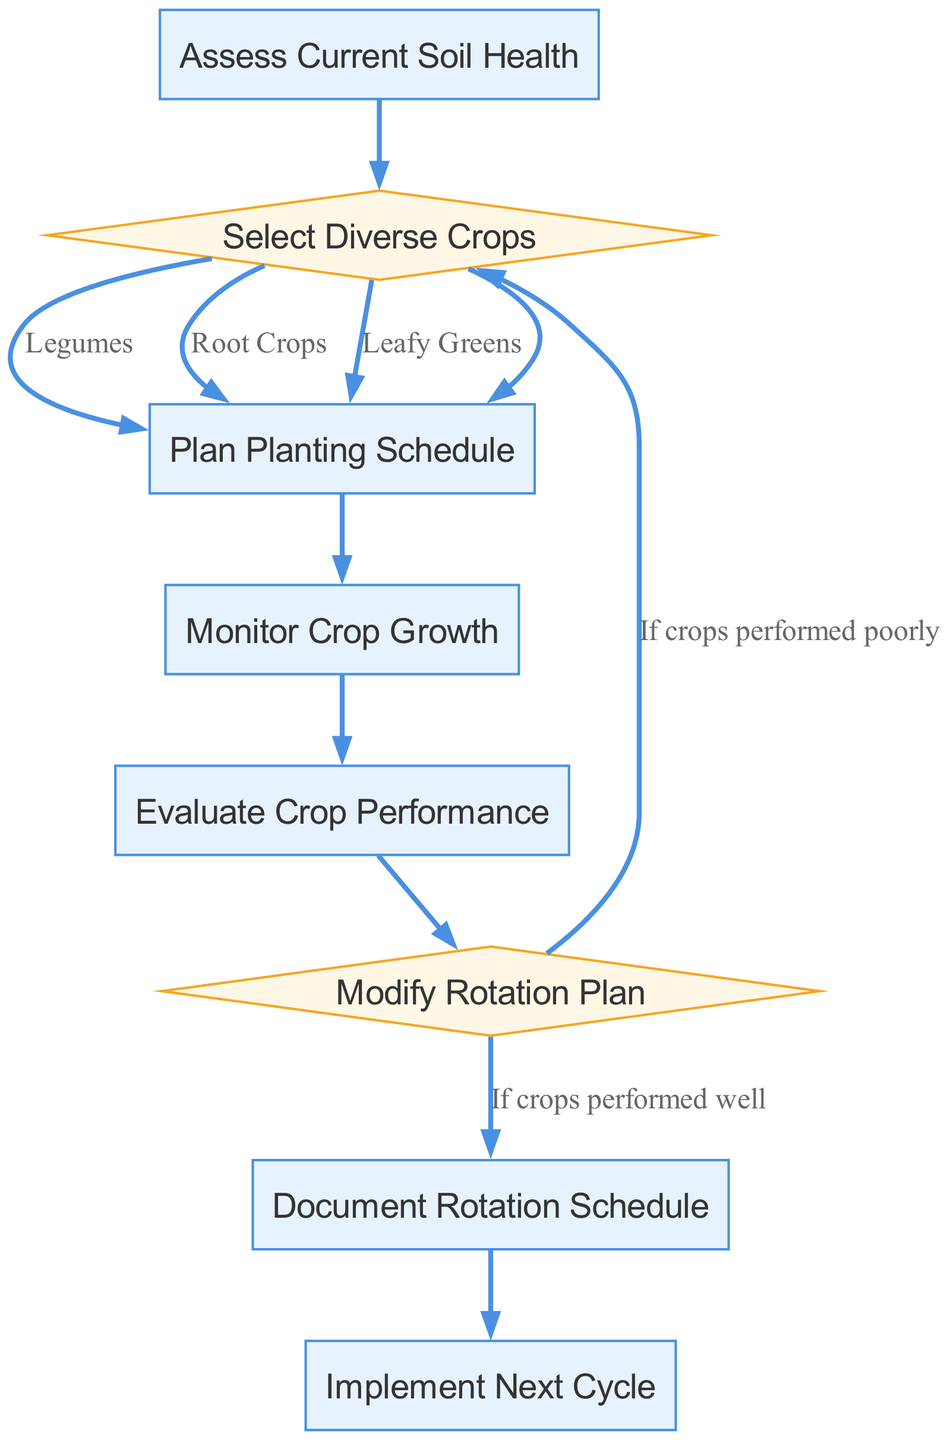What is the first step in the flowchart? The first step is "Assess Current Soil Health," which is indicated as the starting point in the flowchart.
Answer: Assess Current Soil Health How many types of crops can be selected? There are three types of crops mentioned in the crop selection node: Legumes, Root Crops, and Leafy Greens.
Answer: Three What happens after "Plan Planting Schedule"? The next step after "Plan Planting Schedule" is "Monitor Crop Growth," which follows directly in the flowchart.
Answer: Monitor Crop Growth What decision follows "Evaluate Crop Performance"? The decision that follows "Evaluate Crop Performance" is "Modify Rotation Plan," which determines the next actions based on crop performance.
Answer: Modify Rotation Plan What do you do if crops performed well? If crops performed well, you proceed to "Document Rotation Schedule," as indicated in the options from the decision point "Modify Rotation Plan."
Answer: Document Rotation Schedule What is the final step in this flowchart? The final step specified in the flowchart is "Implement Next Cycle," which is the end point after documenting the rotation schedule.
Answer: Implement Next Cycle How many processes are there in the flowchart? The flowchart contains six process nodes: "Assess Current Soil Health," "Plan Planting Schedule," "Monitor Crop Growth," "Evaluate Crop Performance," "Document Rotation Schedule," and "Implement Next Cycle."
Answer: Six What does the decision node "Modify Rotation Plan" lead to if crops performed poorly? If crops performed poorly, the decision node "Modify Rotation Plan" leads back to "Select Diverse Crops," indicating a reevaluation of crop choices.
Answer: Select Diverse Crops What color are the process nodes in the flowchart? The process nodes are colored with a filled color of light blue, specifically the hex color #E6F3FF in the diagram.
Answer: Light blue 